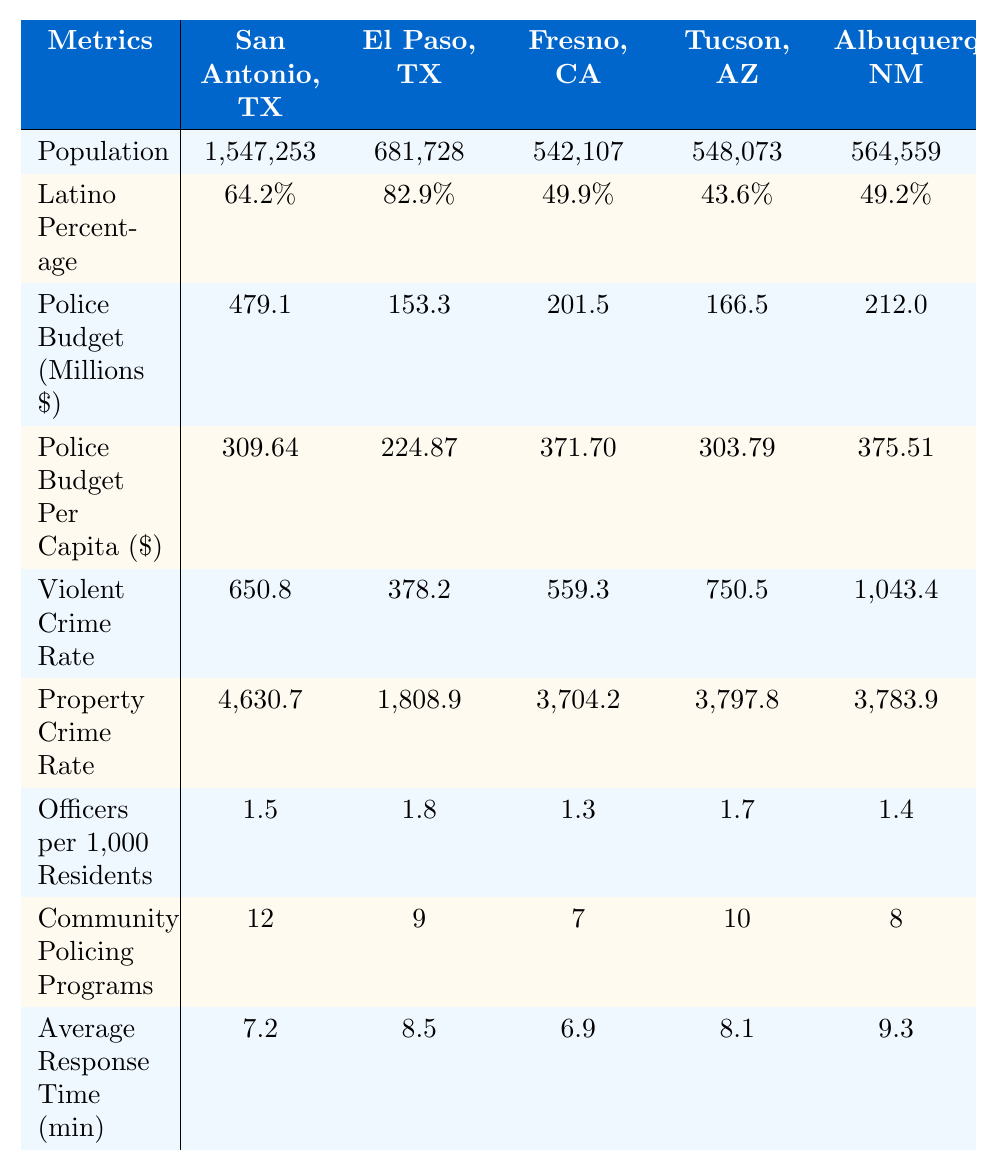What is the police budget for San Antonio, TX? The table shows a specific row for "Police Budget (Millions $)" for San Antonio, which lists the amount as 479.1 million dollars.
Answer: 479.1 million dollars Which city has the highest property crime rate? By comparing the "Property Crime Rate" values, Albuquerque, NM has the highest rate at 3783.9.
Answer: Albuquerque, NM What is the average number of officers per 1,000 residents across all cities? To find the average, sum the values for "Officers per 1,000 Residents": (1.5 + 1.8 + 1.3 + 1.7 + 1.4 = 7.7), then divide by the total number of cities (5): 7.7 / 5 = 1.54.
Answer: 1.54 What percentage of the population in El Paso, TX is Latino? The "Latino Percentage" for El Paso, TX is clearly indicated as 82.9% in the respective row of the table.
Answer: 82.9% Does Fresno, CA have more or less community policing programs than San Antonio, TX? The table shows that Fresno, CA has 7 community policing programs, while San Antonio, TX has 12 programs. Since 12 > 7, San Antonio has more programs.
Answer: More Which city has the lowest violent crime rate? Upon reviewing the "Violent Crime Rate" data, El Paso, TX, with a rate of 378.2, has the lowest rate among the listed cities.
Answer: El Paso, TX By how much does the police budget per capita differ between Albuquerque, NM and Tucson, AZ? To find the difference, subtract Tucson’s budget per capita (303.79) from Albuquerque’s (375.51): 375.51 - 303.79 = 71.72.
Answer: 71.72 What is the average response time for police across the cities listed? Sum up the "Average Response Time (min)" values: (7.2 + 8.5 + 6.9 + 8.1 + 9.3 = 39), then divide by the number of cities (5): 39 / 5 = 7.8.
Answer: 7.8 minutes Which city has a higher violent crime rate, Tucson, AZ or San Antonio, TX? The violent crime rates are compared: Tucson, AZ has a rate of 750.5 while San Antonio, TX has 650.8. Since 750.5 > 650.8, Tucson has a higher rate.
Answer: Tucson, AZ Is the population of Fresno, CA larger than that of El Paso, TX? Looking at the population numbers, Fresno has 542,107 while El Paso has 681,728. Since 542,107 < 681,728, Fresno has a smaller population.
Answer: No 